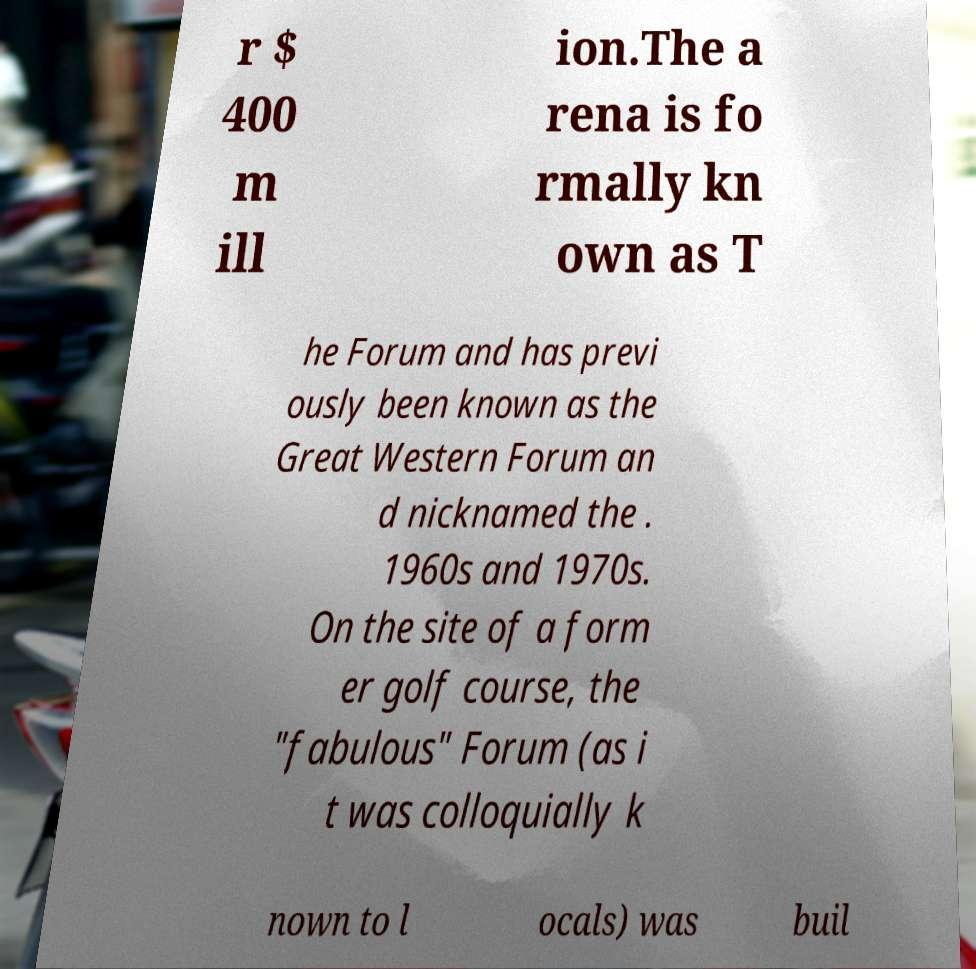What messages or text are displayed in this image? I need them in a readable, typed format. r $ 400 m ill ion.The a rena is fo rmally kn own as T he Forum and has previ ously been known as the Great Western Forum an d nicknamed the . 1960s and 1970s. On the site of a form er golf course, the "fabulous" Forum (as i t was colloquially k nown to l ocals) was buil 